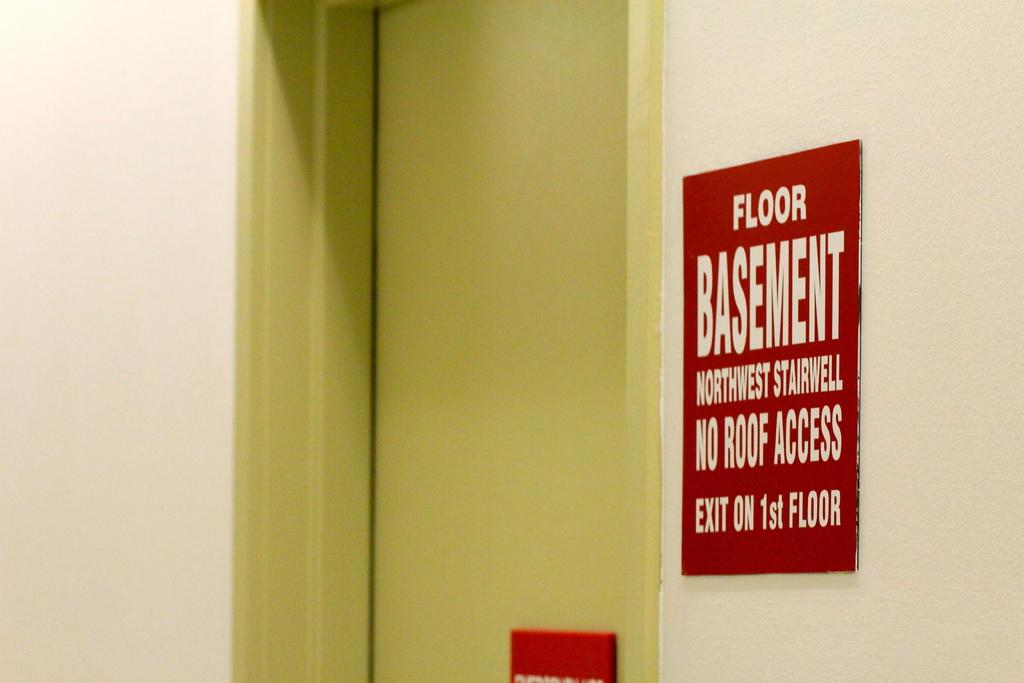<image>
Relay a brief, clear account of the picture shown. A door with a red sign to the right, reading Floor; Basement; Northwest Stairwell; No Roof Access; Exit on 1st Floor. 